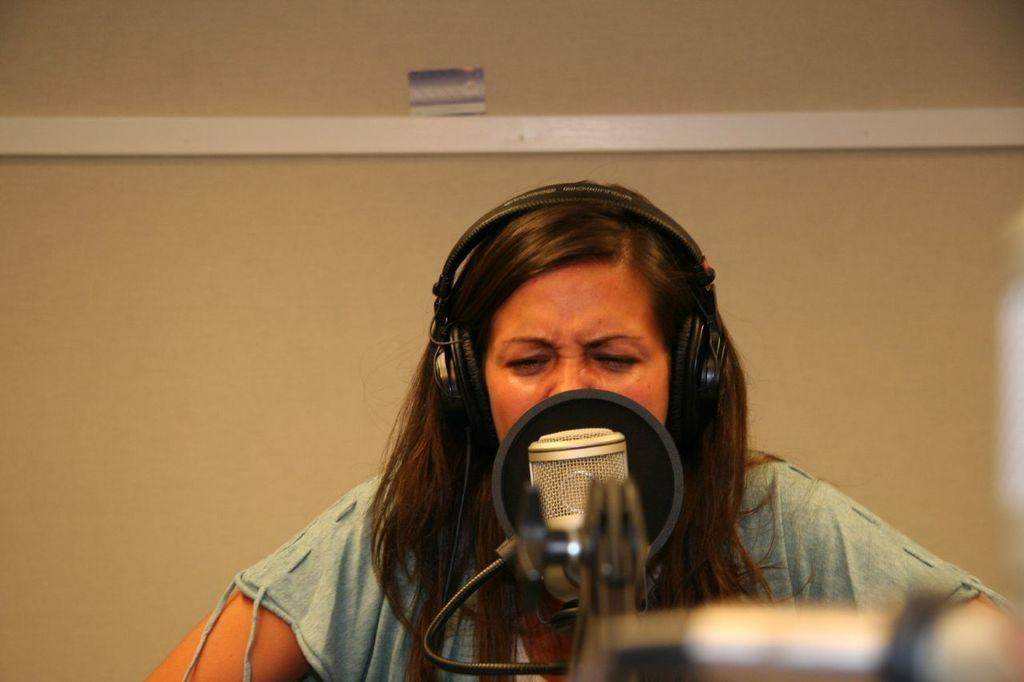Who is the main subject in the image? There is a woman in the image. What object is in front of the woman? There is a microphone in front of the woman. What accessory is the woman wearing? The woman is wearing headphones. What can be seen in the background of the image? There is a wall in the background of the image. What type of milk is being used to write on the chalkboard in the image? There is no chalkboard or milk present in the image. 